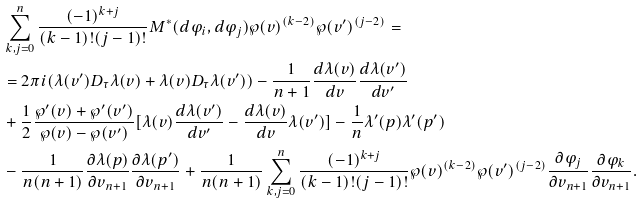Convert formula to latex. <formula><loc_0><loc_0><loc_500><loc_500>& \sum _ { k , j = 0 } ^ { n } \frac { ( - 1 ) ^ { k + j } } { ( k - 1 ) ! ( j - 1 ) ! } M ^ { * } ( d \varphi _ { i } , d \varphi _ { j } ) \wp ( v ) ^ { ( k - 2 ) } \wp ( v ^ { \prime } ) ^ { ( j - 2 ) } = \\ & = 2 \pi i ( \lambda ( v ^ { \prime } ) D _ { \tau } \lambda ( v ) + \lambda ( v ) D _ { \tau } \lambda ( v ^ { \prime } ) ) - \frac { 1 } { n + 1 } \frac { d \lambda ( v ) } { d v } \frac { d \lambda ( v ^ { \prime } ) } { d v ^ { \prime } } \\ & + \frac { 1 } { 2 } \frac { \wp ^ { \prime } ( v ) + \wp ^ { \prime } ( v ^ { \prime } ) } { \wp ( v ) - \wp ( v ^ { \prime } ) } [ \lambda ( v ) \frac { d \lambda ( v ^ { \prime } ) } { d v ^ { \prime } } - \frac { d \lambda ( v ) } { d v } \lambda ( v ^ { \prime } ) ] - \frac { 1 } { n } \lambda ^ { \prime } ( p ) \lambda ^ { \prime } ( p ^ { \prime } ) \\ & - \frac { 1 } { n ( n + 1 ) } \frac { \partial \lambda ( p ) } { \partial v _ { n + 1 } } \frac { \partial \lambda ( p ^ { \prime } ) } { \partial v _ { n + 1 } } + \frac { 1 } { n ( n + 1 ) } \sum _ { k , j = 0 } ^ { n } \frac { ( - 1 ) ^ { k + j } } { ( k - 1 ) ! ( j - 1 ) ! } \wp ( v ) ^ { ( k - 2 ) } \wp ( v ^ { \prime } ) ^ { ( j - 2 ) } \frac { \partial \varphi _ { j } } { \partial v _ { n + 1 } } \frac { \partial \varphi _ { k } } { \partial v _ { n + 1 } } .</formula> 